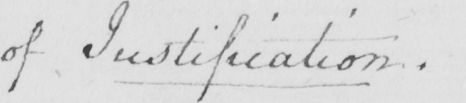What text is written in this handwritten line? of Justification . 